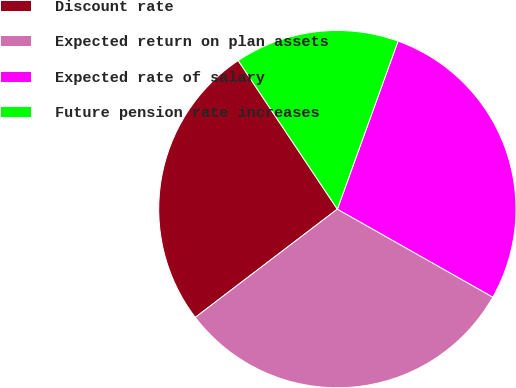Convert chart. <chart><loc_0><loc_0><loc_500><loc_500><pie_chart><fcel>Discount rate<fcel>Expected return on plan assets<fcel>Expected rate of salary<fcel>Future pension rate increases<nl><fcel>26.0%<fcel>31.44%<fcel>27.68%<fcel>14.88%<nl></chart> 